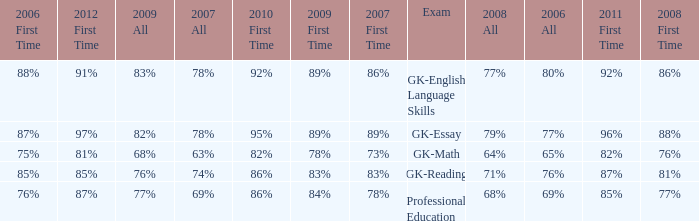What is the percentage for first time in 2012 when it was 82% for all in 2009? 97%. 